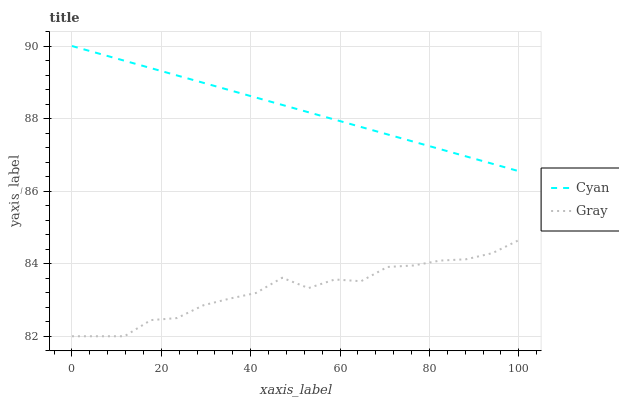Does Gray have the minimum area under the curve?
Answer yes or no. Yes. Does Cyan have the maximum area under the curve?
Answer yes or no. Yes. Does Gray have the maximum area under the curve?
Answer yes or no. No. Is Cyan the smoothest?
Answer yes or no. Yes. Is Gray the roughest?
Answer yes or no. Yes. Is Gray the smoothest?
Answer yes or no. No. Does Gray have the lowest value?
Answer yes or no. Yes. Does Cyan have the highest value?
Answer yes or no. Yes. Does Gray have the highest value?
Answer yes or no. No. Is Gray less than Cyan?
Answer yes or no. Yes. Is Cyan greater than Gray?
Answer yes or no. Yes. Does Gray intersect Cyan?
Answer yes or no. No. 